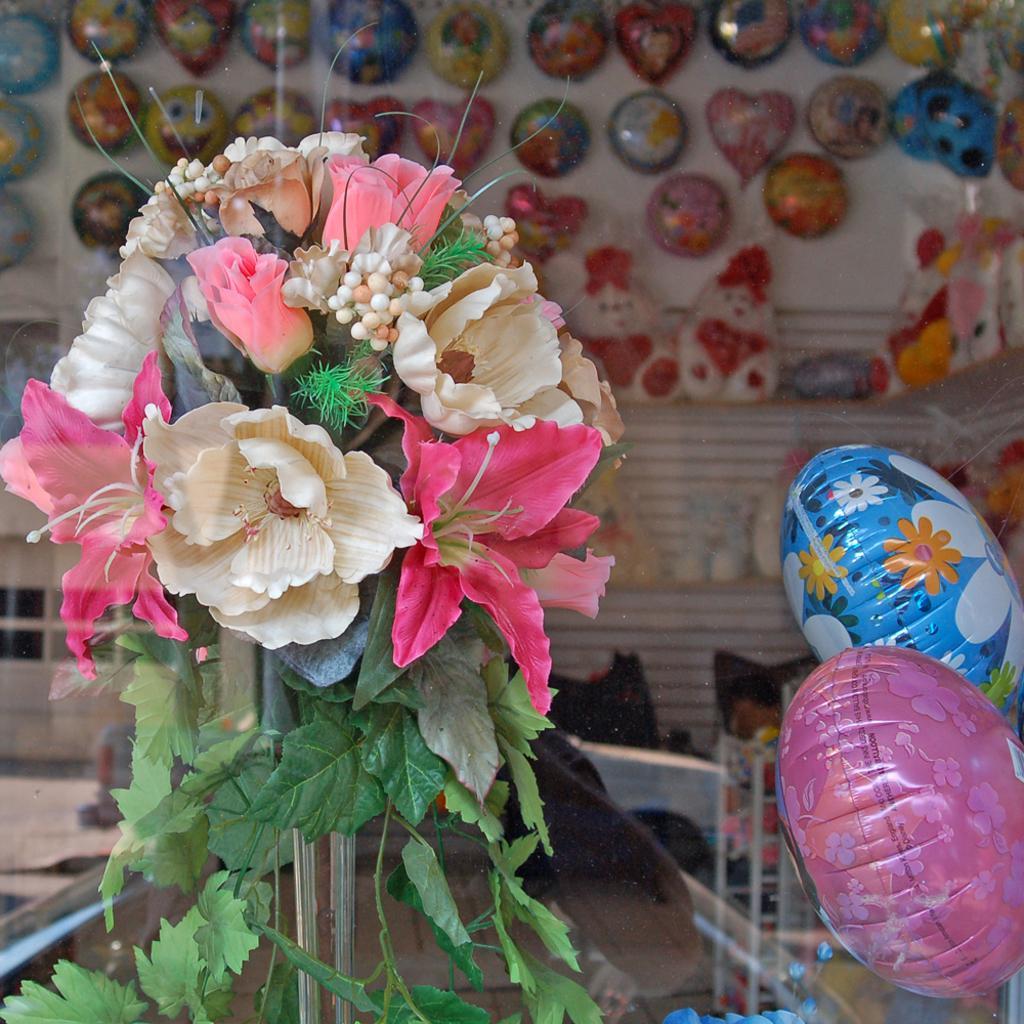Describe this image in one or two sentences. In this image, we can see a flower bouquet and rods. On the right side, we can see two balloons. Background we can see a glass object. Through the glass, we can see balloons, wall and few things. 